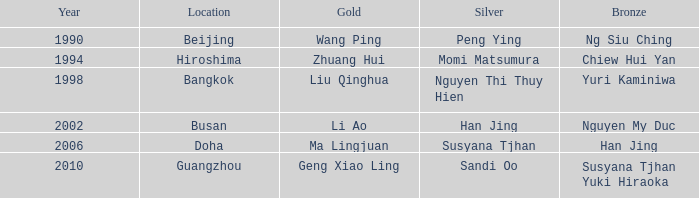What's the lowest Year with the Location of Bangkok? 1998.0. 